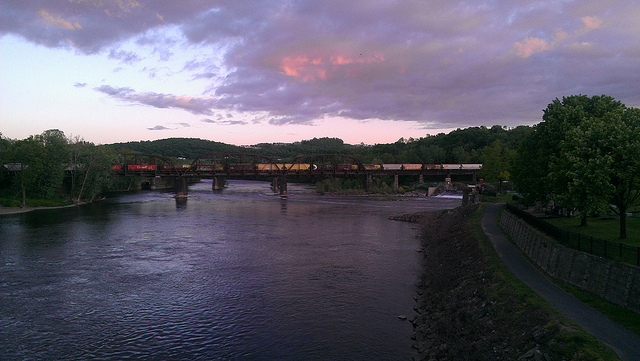<image>Could the camera be pointing west? It is ambiguous whether the camera could be pointing west. What lake is the name of the lake? I don't know the name of the lake. It could be Michigan, Huron, Potomac, or Lake Norman. Could the camera be pointing west? I don't know if the camera could be pointing west. It is possible, but I cannot say for sure. What lake is the name of the lake? I am not sure what lake is the name of the lake. It can be seen 'michigan', 'huron', 'calm', 'potomac', 'michigan lake', 'lake', 'lake norman' or it can be unknown. 